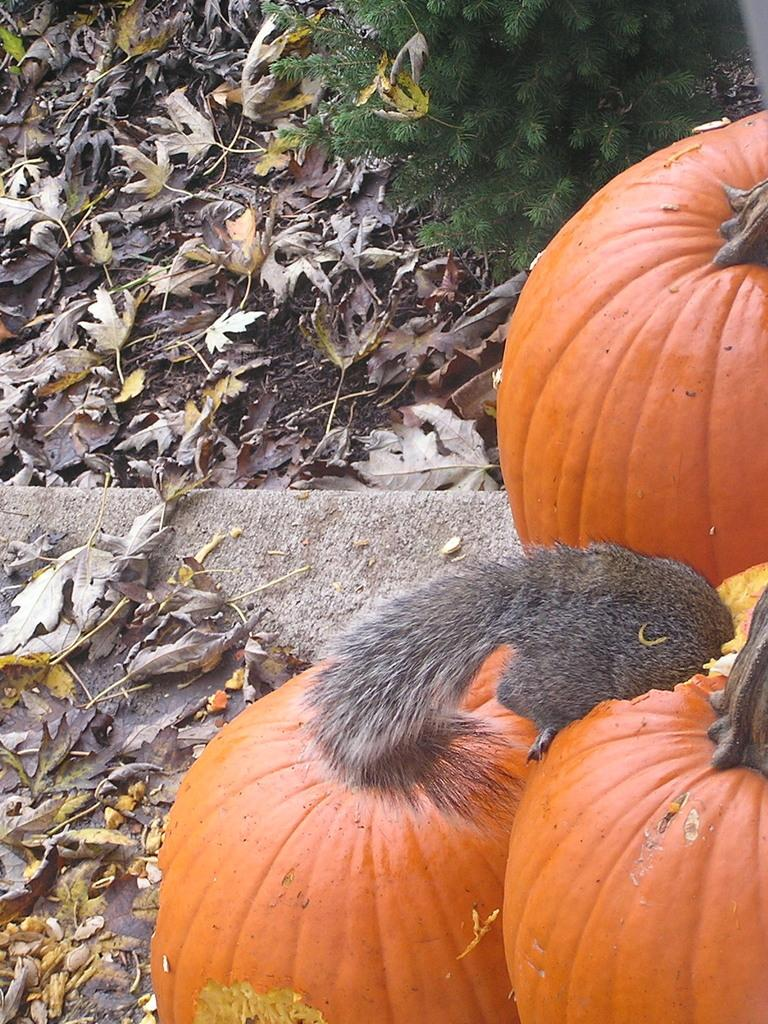How many pumpkins are visible in the image? There are three pumpkins in the image. What type of animal can be seen in the image? There is an animal in the image. What can be found on the ground in the image? There are dried leaves in the image. What type of plant is present in the image? There is a plant in the image. Where is the office located in the image? There is no office present in the image. Who is the parent of the animal in the image? The image does not provide information about the animal's parent. 